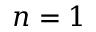Convert formula to latex. <formula><loc_0><loc_0><loc_500><loc_500>n = 1</formula> 